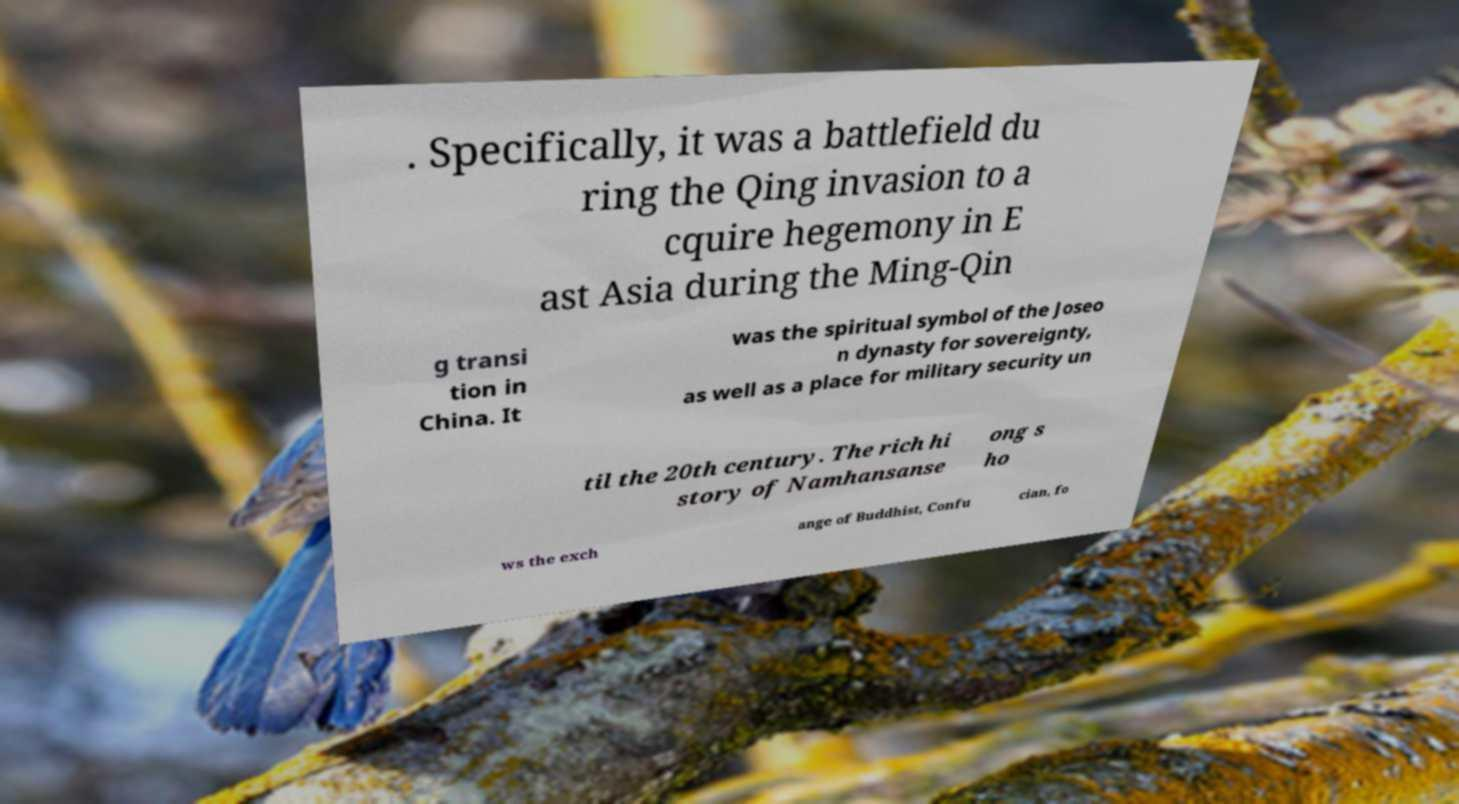Can you accurately transcribe the text from the provided image for me? . Specifically, it was a battlefield du ring the Qing invasion to a cquire hegemony in E ast Asia during the Ming-Qin g transi tion in China. It was the spiritual symbol of the Joseo n dynasty for sovereignty, as well as a place for military security un til the 20th century. The rich hi story of Namhansanse ong s ho ws the exch ange of Buddhist, Confu cian, fo 